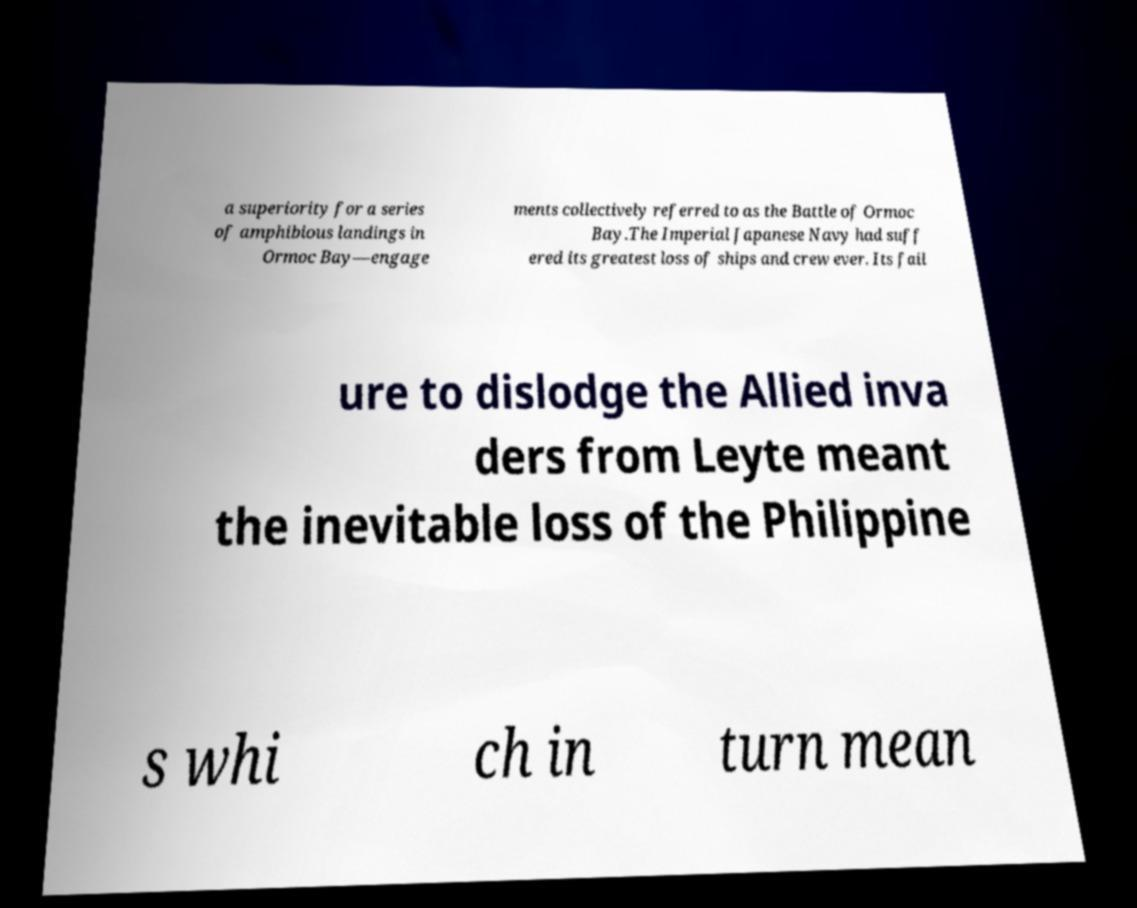Could you assist in decoding the text presented in this image and type it out clearly? a superiority for a series of amphibious landings in Ormoc Bay—engage ments collectively referred to as the Battle of Ormoc Bay.The Imperial Japanese Navy had suff ered its greatest loss of ships and crew ever. Its fail ure to dislodge the Allied inva ders from Leyte meant the inevitable loss of the Philippine s whi ch in turn mean 